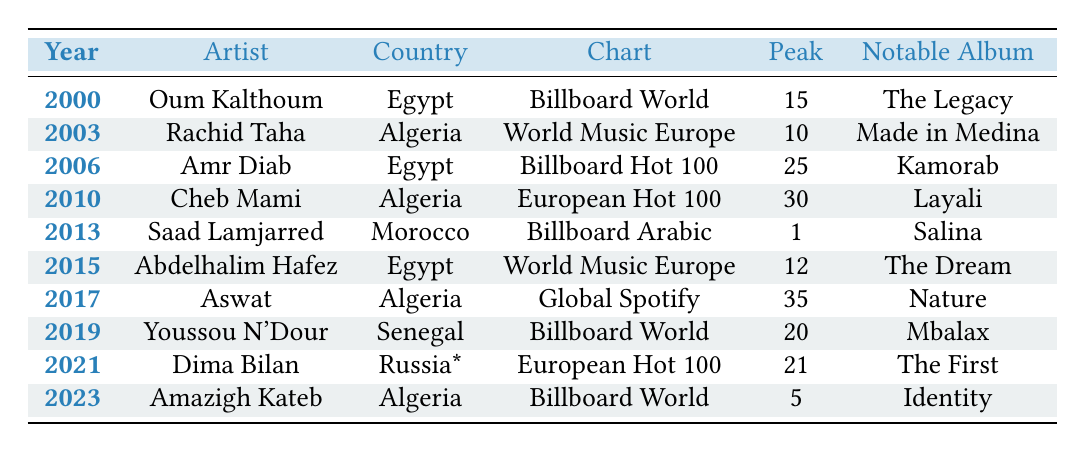What is the peak position of Saad Lamjarred in the Billboard Arabic Charts in 2013? The table shows that Saad Lamjarred peaked at position 1 in the Billboard Arabic Charts in 2013.
Answer: 1 Which artist from Egypt had the highest peak position in the charts? Analyzing the data, Saad Lamjarred is from Morocco and peaked at position 1, whereas Oum Kalthoum reached position 15, and Amr Diab peaked at 25. Therefore, the highest peak from Egypt is Amr Diab.
Answer: 25 Was there a North African artist that peaked at position 10 or higher after 2010? Checking the years after 2010, Saad Lamjarred peaked at position 1 in 2013, which is higher than 10.
Answer: Yes How many different charts did North African musicians feature in from 2000 to 2023? The table lists four unique charts: Billboard World Music Charts, World Music Charts Europe, Billboard Hot 100, and European Hot 100.
Answer: 4 What is the median peak position of North African musicians in the given time period? The peak positions (15, 10, 25, 30, 1, 12, 35, 20, 21, 5) are sorted to (1, 5, 10, 12, 15, 20, 21, 25, 30, 35), with the median being the average of the 5th and 6th positions: (15 + 20) / 2 = 17.5.
Answer: 17.5 What is the notable album of the artist who peaked at the highest position in 2023? Looking at 2023, Amazigh Kateb peaked at 5, and the notable album listed is "Identity".
Answer: Identity Did any artist reach the peak position of 30 in the charts? The table shows that Cheb Mami reached position 30 in the European Hot 100 in 2010, confirming that it was reached.
Answer: Yes Which country had the highest peak position in the charts according to the data? The significant peak positions are: Egypt (25), Algeria (10, 5), Morocco (1), and Senegal (20). The highest position is 1 from Morocco (Saad Lamjarred).
Answer: Morocco How many artists represented Algeria in the global music charts? The data shows two artists from Algeria: Rachid Taha and Cheb Mami.
Answer: 2 In which year did Rachid Taha achieve his peak position? The table indicates that Rachid Taha peaked in 2003.
Answer: 2003 Was Amazigh Kateb the only Algerian artist to appear in the Billboard World Music Charts? The data shows that Oum Kalthoum and Amazigh Kateb both appeared in the Billboard World Music Charts, so Amazigh Kateb was not the only one.
Answer: No 